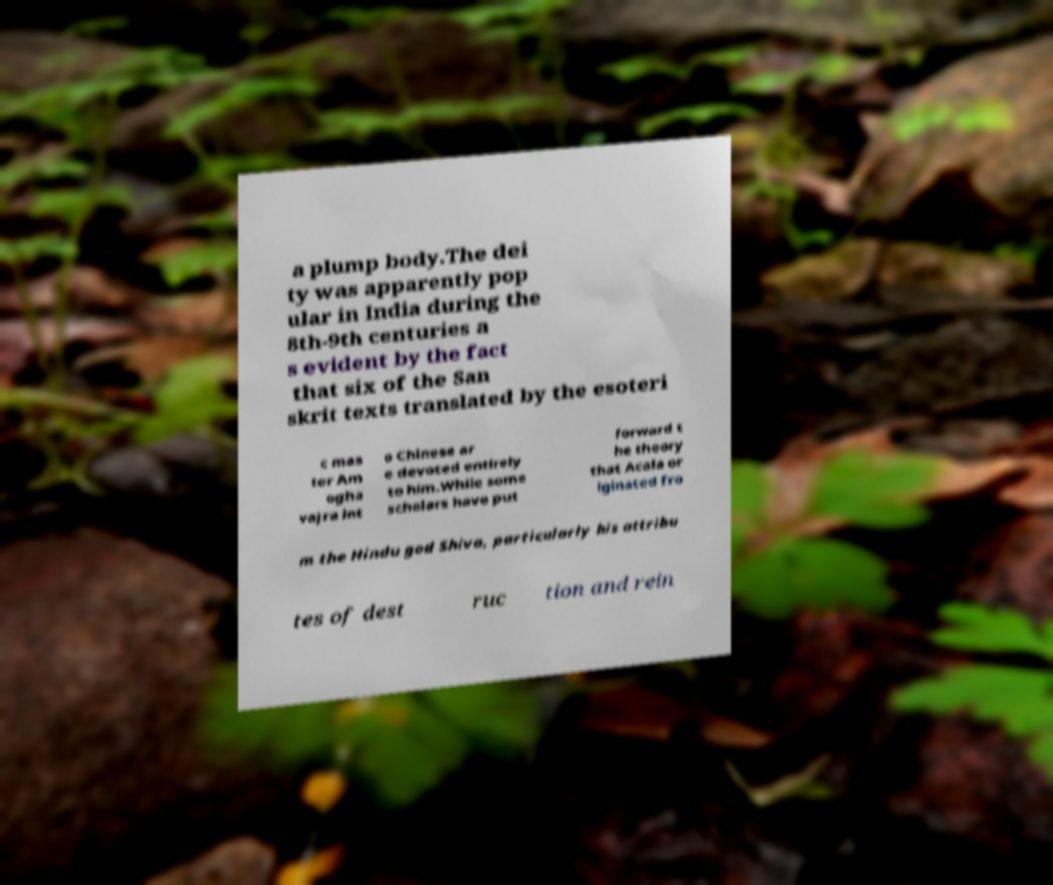Can you read and provide the text displayed in the image?This photo seems to have some interesting text. Can you extract and type it out for me? a plump body.The dei ty was apparently pop ular in India during the 8th-9th centuries a s evident by the fact that six of the San skrit texts translated by the esoteri c mas ter Am ogha vajra int o Chinese ar e devoted entirely to him.While some scholars have put forward t he theory that Acala or iginated fro m the Hindu god Shiva, particularly his attribu tes of dest ruc tion and rein 